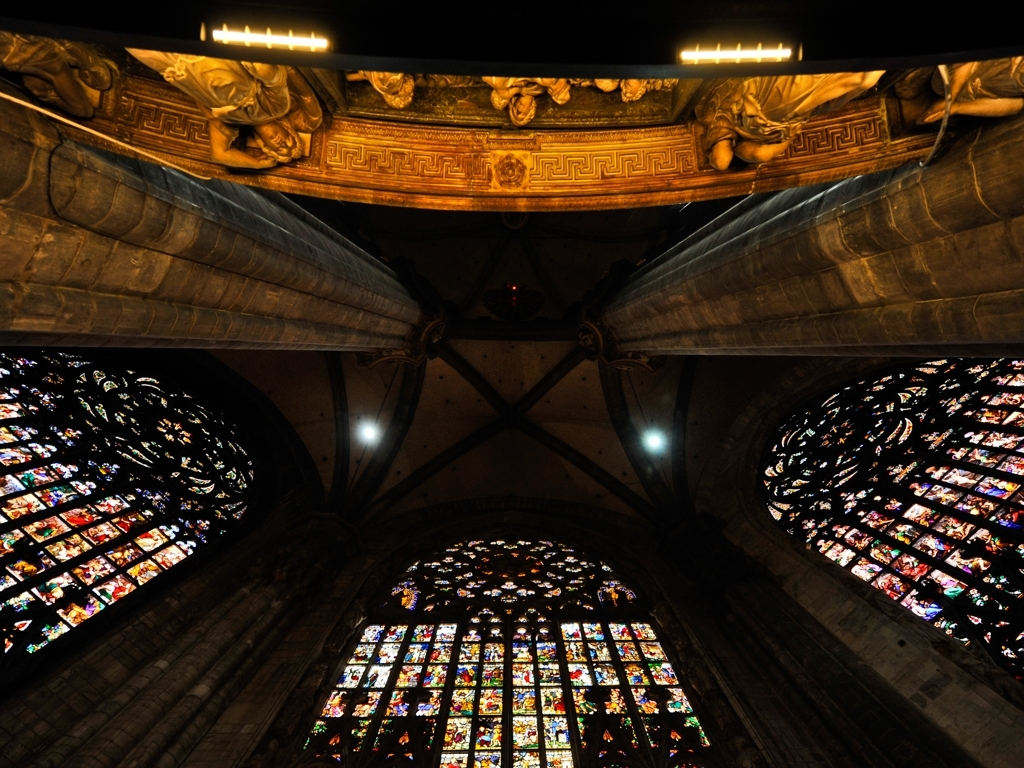Could you describe the architectural style captured in this image? The architectural style in the image is Gothic, characterized by its pointed arches, ribbed vaults, and flying buttresses. The rose windows and intricate tracery also exemplify this style, typically seen in cathedrals and churches from the late medieval period. 